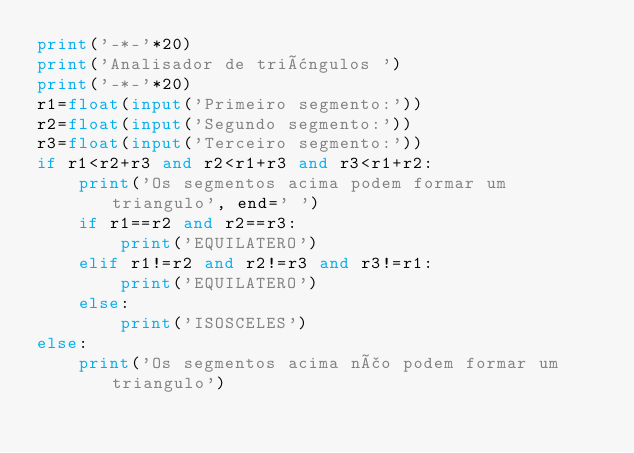<code> <loc_0><loc_0><loc_500><loc_500><_Python_>print('-*-'*20)
print('Analisador de triângulos ')
print('-*-'*20)
r1=float(input('Primeiro segmento:'))
r2=float(input('Segundo segmento:'))
r3=float(input('Terceiro segmento:'))
if r1<r2+r3 and r2<r1+r3 and r3<r1+r2:
    print('Os segmentos acima podem formar um triangulo', end=' ')
    if r1==r2 and r2==r3:
        print('EQUILATERO')
    elif r1!=r2 and r2!=r3 and r3!=r1:
        print('EQUILATERO')
    else:
        print('ISOSCELES')
else:
    print('Os segmentos acima não podem formar um triangulo')

</code> 